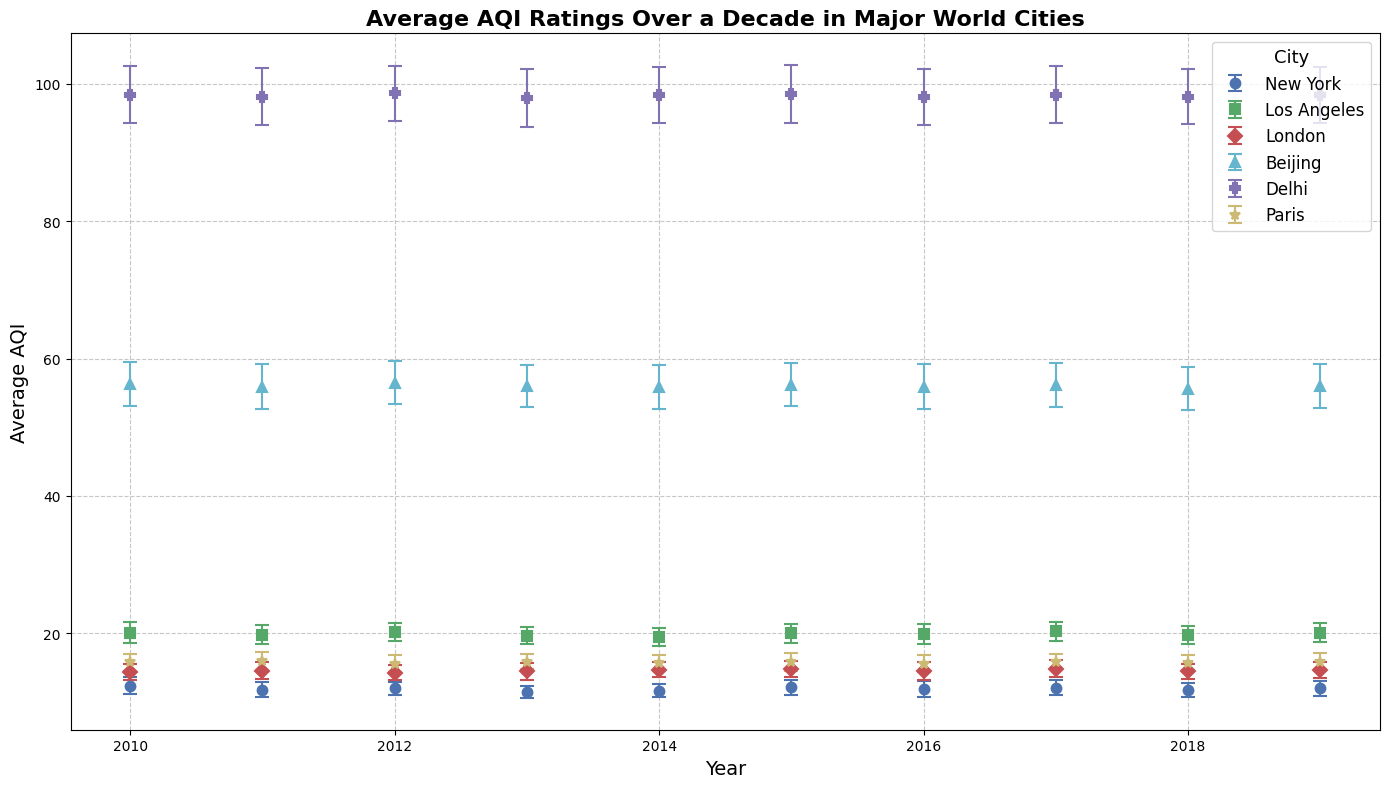Which city has the highest average AQI over the decade? To find the city with the highest average AQI, compare the values reported for all cities. By examining the figure, Delhi consistently shows values around 98, which is significantly higher than the other cities.
Answer: Delhi How did the AQI in Los Angeles change over the years 2010 to 2019? Look at the error bars and markers for Los Angeles from 2010 to 2019. The AQI values in Los Angeles show fluctuations but remain relatively consistent around the 20 mark with slight variations.
Answer: Relatively consistent, around 20 Between London and Paris, which city shows more variation in AQI over the decade? Compare the error bars length for London and Paris. Lengthier error bars indicate higher variability. Both cities' AQI values are fairly stable but Paris shows slightly greater variability due to more fluctuation in its AQI values.
Answer: Paris In which year did Beijing have the lowest AQI, and what was the value? Examine the data points for Beijing. The lowest value is around 55.6 in the year 2018.
Answer: 2018, 55.6 What is the average AQI in New York over the years 2010 to 2019? Calculate the sum of AQI values for New York from 2010 to 2019 and divide by the number of years: (12.4+11.8+12.0+11.5+11.7+12.2+11.9+12.1+11.8+12.0) / 10 = 11.94
Answer: 11.94 Which city has the visually thickest error bars, and what does this indicate? Compare the thickness of the error bars across all cities. Delhi has the thickest error bars indicating higher variability and uncertainty in its AQI measurements across the decade.
Answer: Delhi By observation, which city’s AQI seems to be the most stable over the decade? Stability can be inferred from consistent AQI values and shorter error bars. New York’s AQI values are relatively consistent with low variation in error bars, suggesting it is the most stable.
Answer: New York How do the AQI levels of Delhi and Beijing compare in 2019? Observe the markers and error bars for both cities in 2019. Delhi has an AQI of 98.3, while Beijing has an AQI of 56.0, indicating Delhi has a worse air quality.
Answer: Delhi has worse AQI What trend can be observed in the AQI of London over the decade? Look at the markers for London from 2010 to 2019. The AQI values for London are fairly steady with minor fluctuations, suggesting no significant upward or downward trend.
Answer: No significant trend, fairly steady 